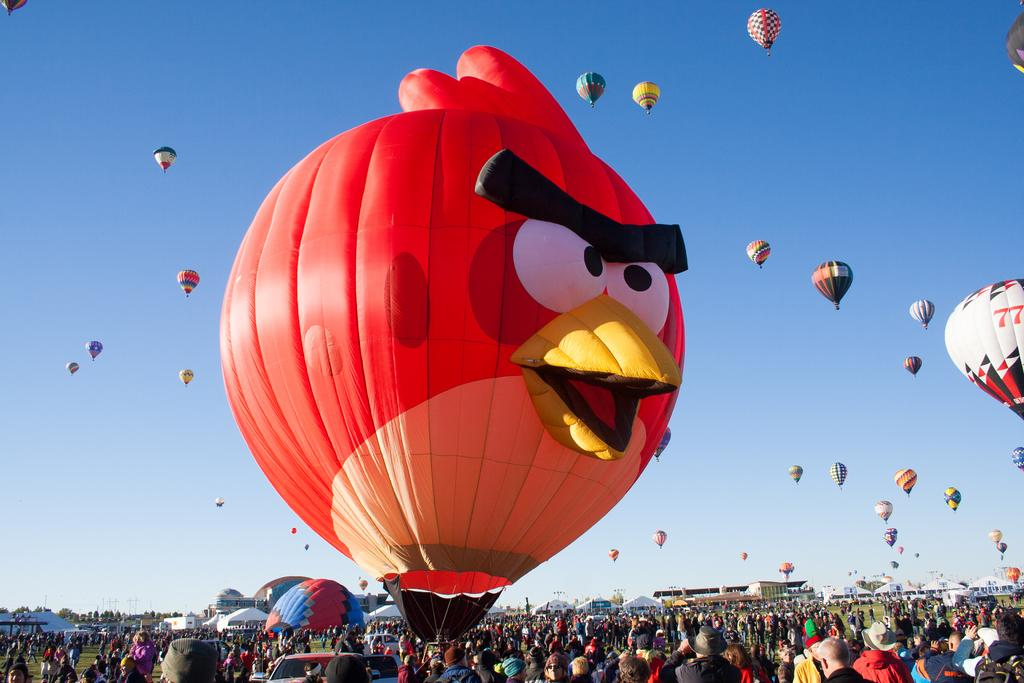What is the surface on which the people are standing in the image? The people are standing on a greenery ground in the image. What can be seen in the sky in the image? There are gas balloons in the sky in the image. Can you describe one of the gas balloons in the image? One of the gas balloons is in the shape of an angry bird. How many laborers are working on the expansion of the greenery ground in the image? There is no mention of laborers or an expansion project in the image. What does your aunt think about the angry bird gas balloon in the image? There is no information about your aunt's opinion in the image, as it only shows people standing on a greenery ground and gas balloons in the sky. 